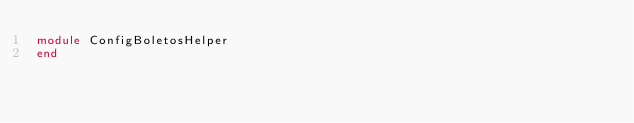<code> <loc_0><loc_0><loc_500><loc_500><_Ruby_>module ConfigBoletosHelper
end
</code> 